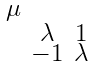<formula> <loc_0><loc_0><loc_500><loc_500>\begin{smallmatrix} \mu & & \\ & \lambda & 1 \\ & - 1 & \lambda \end{smallmatrix}</formula> 